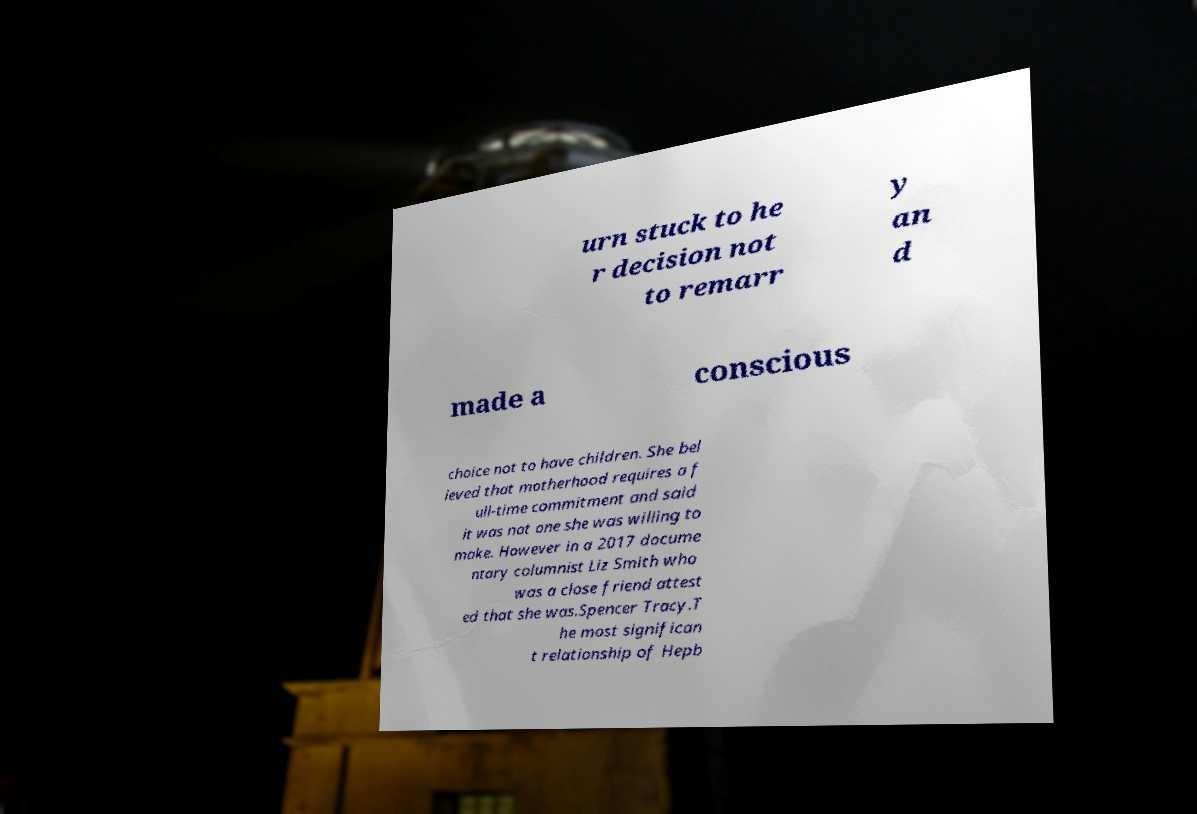Could you assist in decoding the text presented in this image and type it out clearly? urn stuck to he r decision not to remarr y an d made a conscious choice not to have children. She bel ieved that motherhood requires a f ull-time commitment and said it was not one she was willing to make. However in a 2017 docume ntary columnist Liz Smith who was a close friend attest ed that she was.Spencer Tracy.T he most significan t relationship of Hepb 